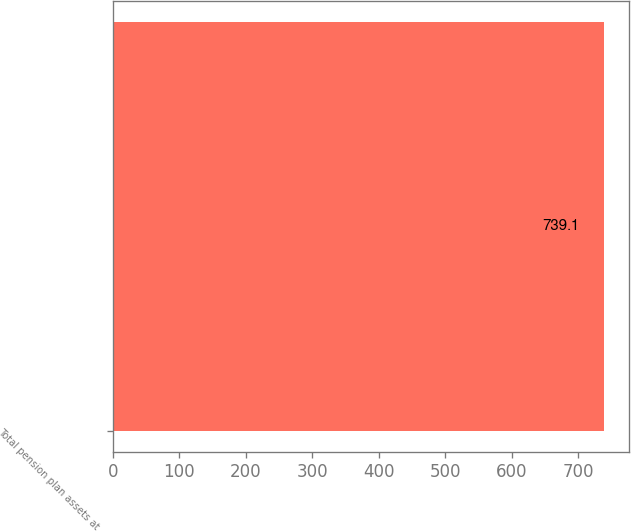Convert chart to OTSL. <chart><loc_0><loc_0><loc_500><loc_500><bar_chart><fcel>Total pension plan assets at<nl><fcel>739.1<nl></chart> 